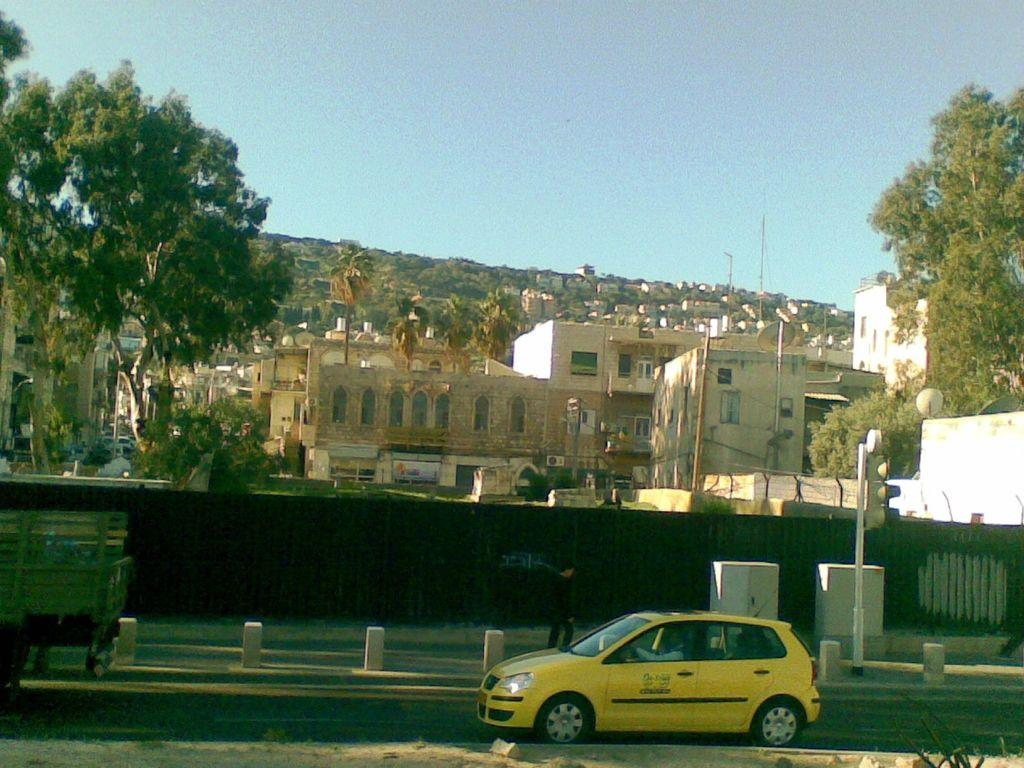What can be seen on the road in the image? There are vehicles on the road in the image. What is visible in the background of the image? There are buildings and trees in the background of the image. How many arms are visible in the image? There are no arms visible in the image. What type of question is being asked in the image? There is no question being asked in the image. 